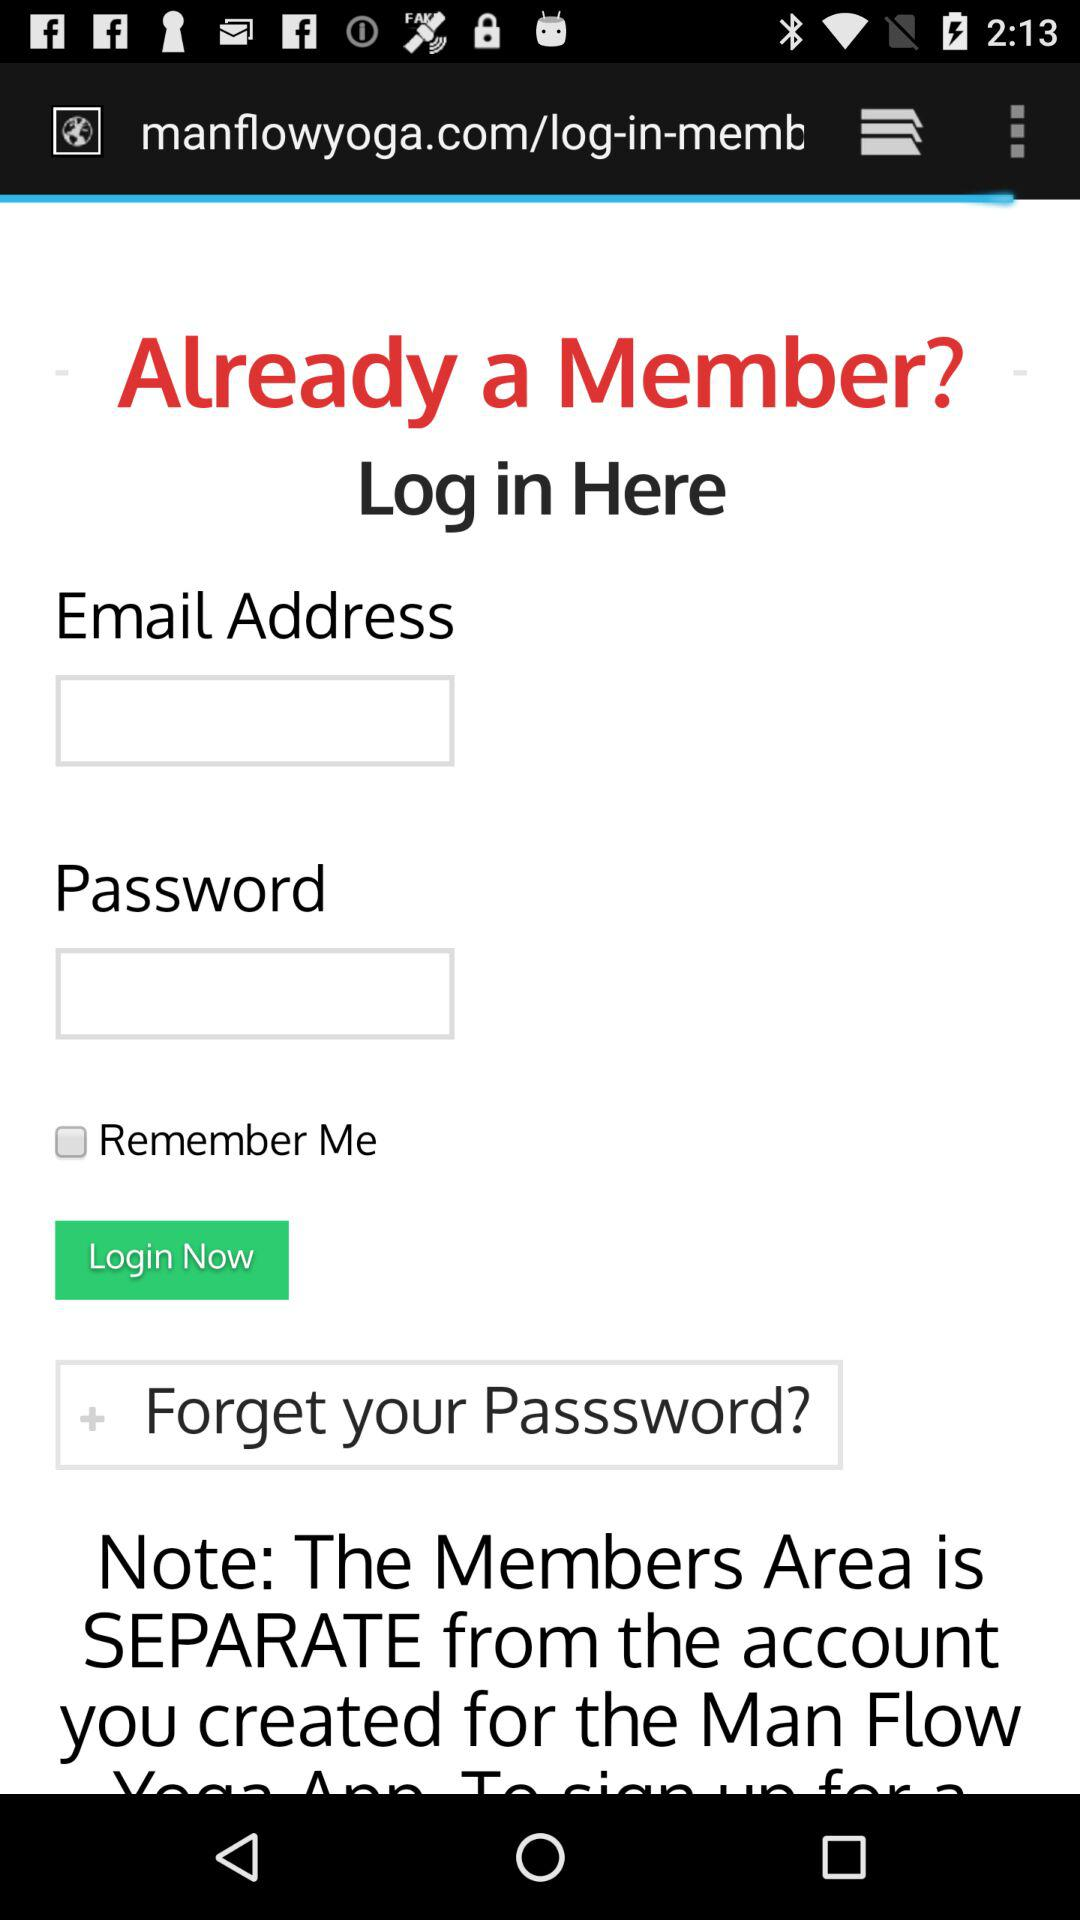What is the status of "Remember Me"? The status is "off". 